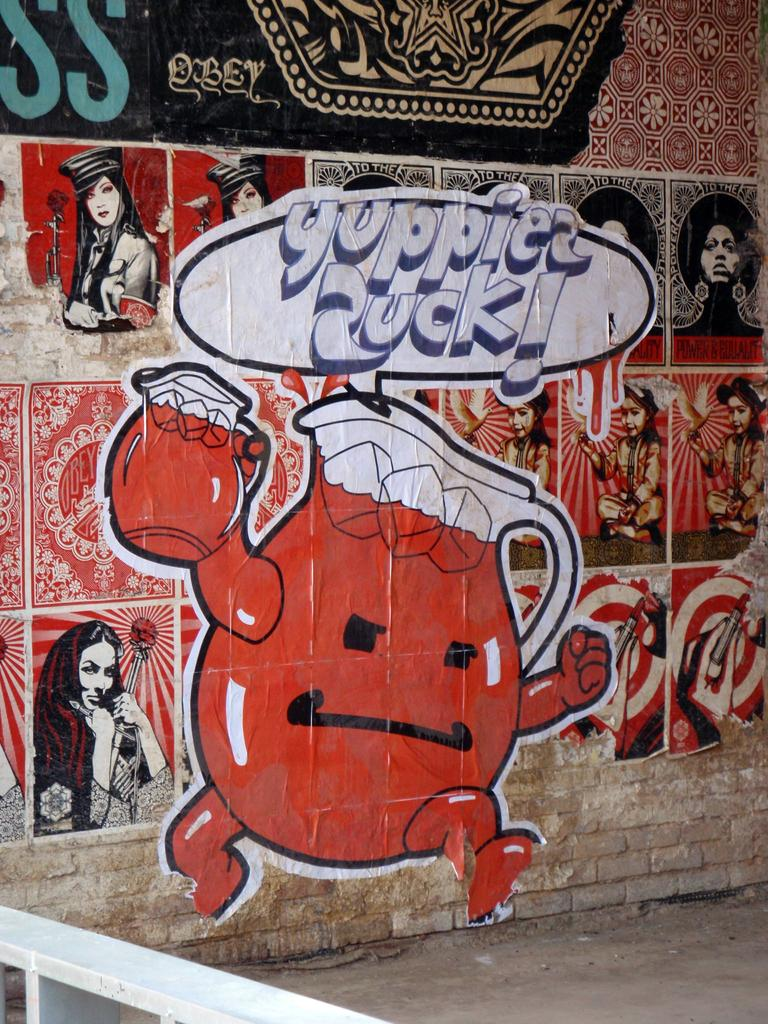What is depicted on the wall in the image? There are paintings of cartoons on the wall in the image. What type of path can be seen in the image? There is a path in the image. What part of the railing is visible in the image? A part of the railing is visible in the image. What color is the railing? The railing is white in color. What story is being told by the flame in the image? There is no flame present in the image, so no story can be told by it. What type of account is being kept by the railing in the image? The railing is not an account-keeping object, so no account can be kept by it. 